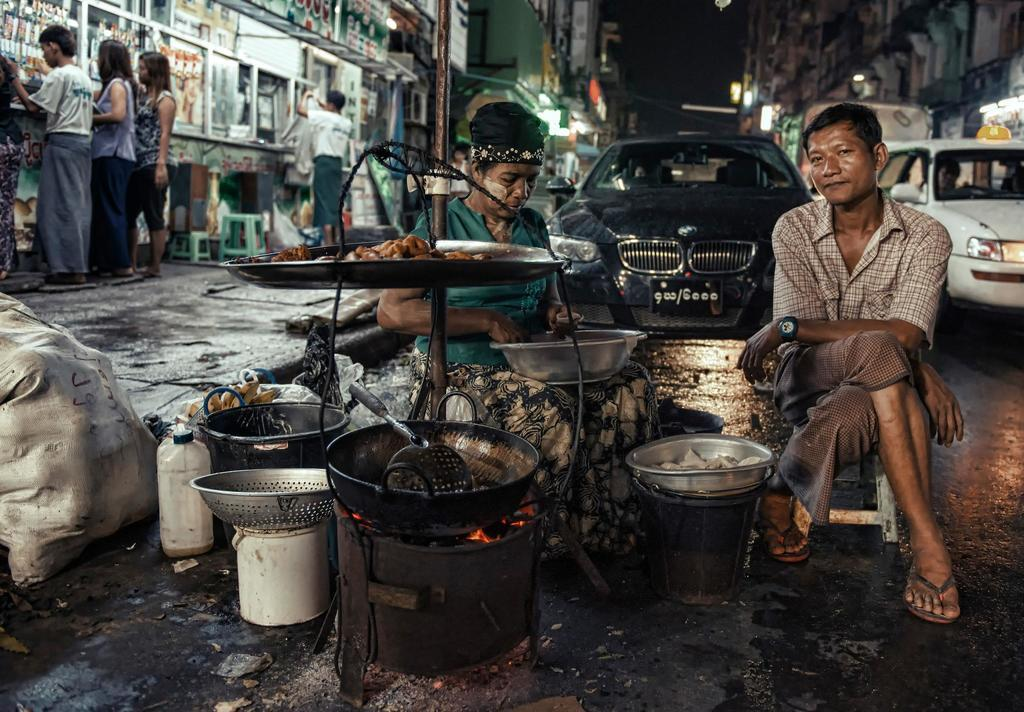How many people can be seen in the image? There are people in the image, but the exact number cannot be determined from the provided facts. What types of vehicles are present in the image? There are vehicles in the image, but the specific types cannot be determined from the provided facts. What is the primary surface in the image? There is a road in the image, which suggests it is a primary surface for vehicles. What might be used for holding food in the image? There are bowls in the image, which can be used for holding food. What is being carried in the image? There is a bag in the image, which suggests something is being carried. What might be used for watering plants in the image? There is a water can in the image, which can be used for watering plants. What is being prepared or cooked in the image? There is a stove in the image, which suggests that something is being prepared or cooked. What structures are visible in the image? There are buildings in the image, which are structures typically used for living or working. What might be used for sitting in the image? There are stools in the image, which can be used for sitting. What might provide illumination in the image? There are lights in the image, which can provide illumination. What might be used for displaying information or advertisements in the image? There are boards in the image, which can be used for displaying information or advertisements. What other objects can be seen in the image? There are other objects in the image, but their specific nature cannot be determined from the provided facts. How many bikes are riding on the waves in the image? There are no bikes or waves present in the image. What type of fall can be seen in the image? There is no fall or any indication of a fall in the image. 